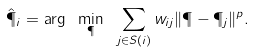Convert formula to latex. <formula><loc_0><loc_0><loc_500><loc_500>\hat { \P } _ { i } = \arg \ \min _ { \P } \ \sum _ { j \in S ( i ) } w _ { i j } \| \P - \P _ { j } \| ^ { p } .</formula> 